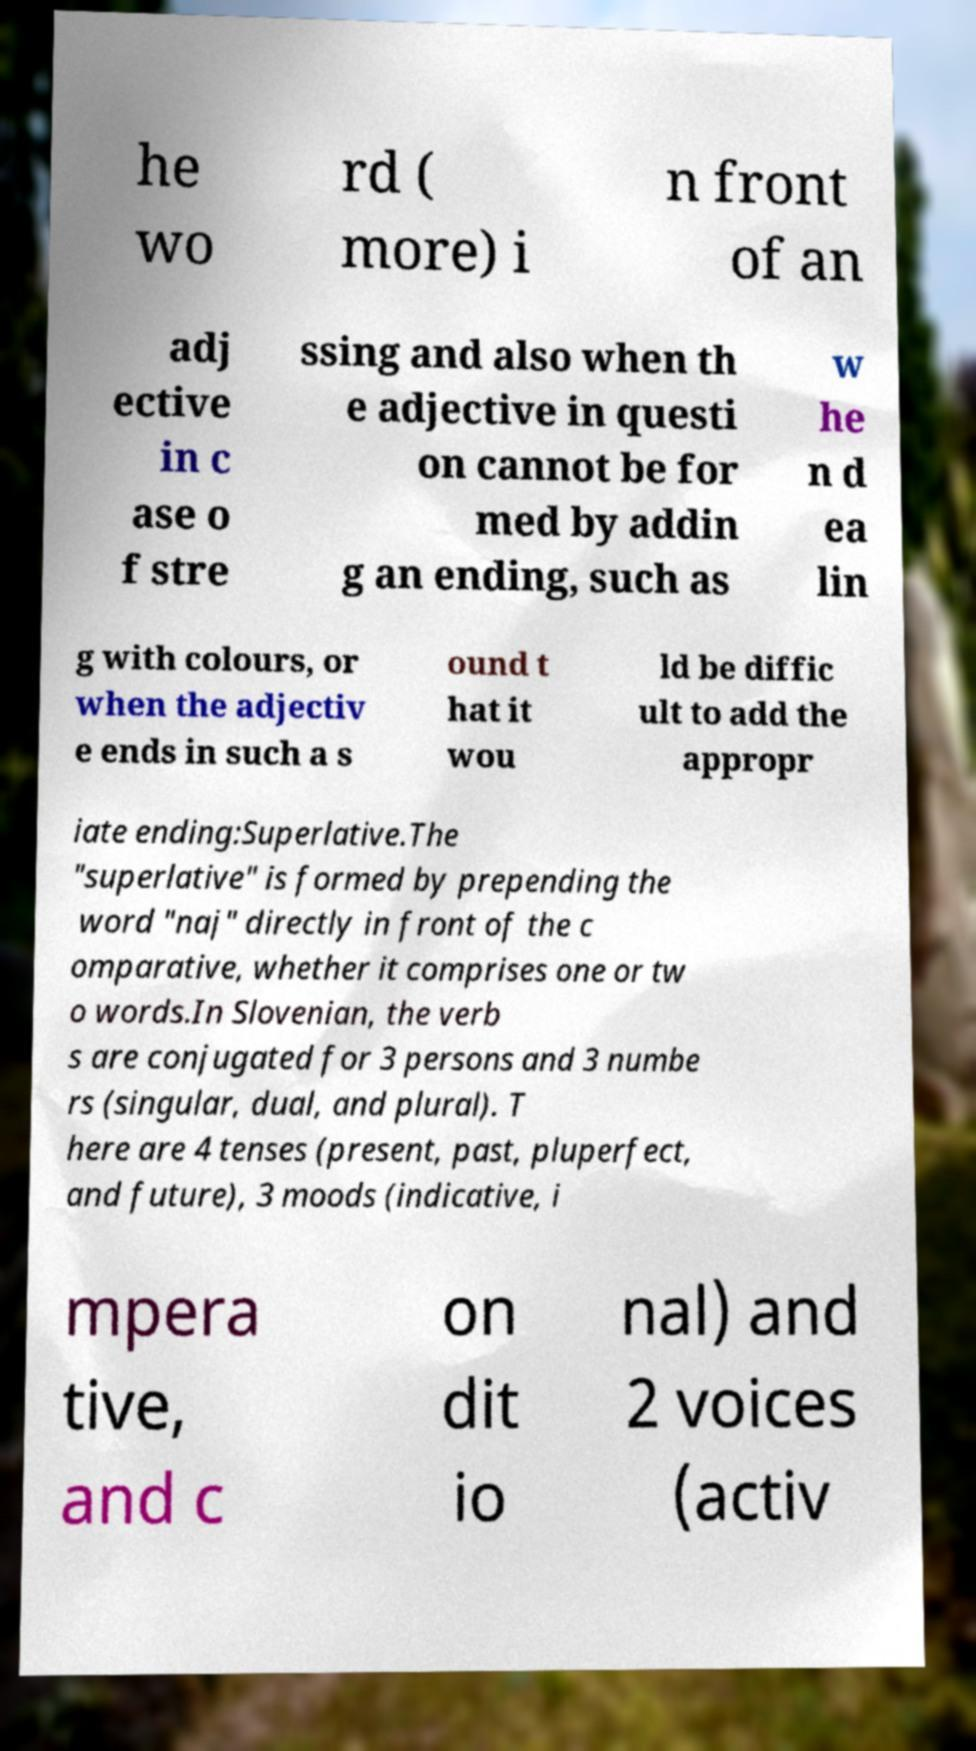Can you read and provide the text displayed in the image?This photo seems to have some interesting text. Can you extract and type it out for me? he wo rd ( more) i n front of an adj ective in c ase o f stre ssing and also when th e adjective in questi on cannot be for med by addin g an ending, such as w he n d ea lin g with colours, or when the adjectiv e ends in such a s ound t hat it wou ld be diffic ult to add the appropr iate ending:Superlative.The "superlative" is formed by prepending the word "naj" directly in front of the c omparative, whether it comprises one or tw o words.In Slovenian, the verb s are conjugated for 3 persons and 3 numbe rs (singular, dual, and plural). T here are 4 tenses (present, past, pluperfect, and future), 3 moods (indicative, i mpera tive, and c on dit io nal) and 2 voices (activ 